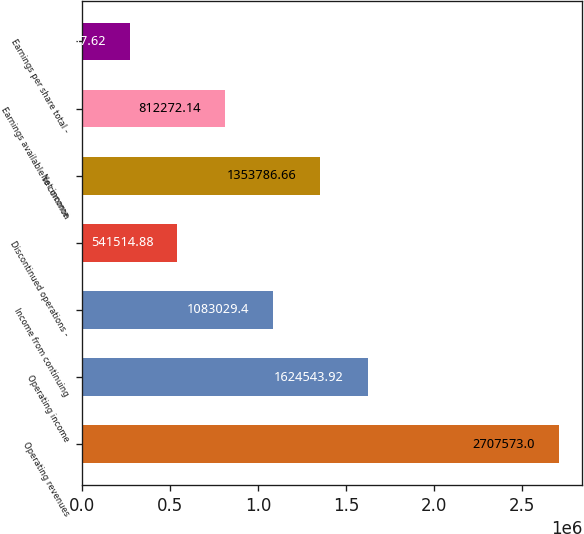Convert chart to OTSL. <chart><loc_0><loc_0><loc_500><loc_500><bar_chart><fcel>Operating revenues<fcel>Operating income<fcel>Income from continuing<fcel>Discontinued operations -<fcel>Net income<fcel>Earnings available to common<fcel>Earnings per share total -<nl><fcel>2.70757e+06<fcel>1.62454e+06<fcel>1.08303e+06<fcel>541515<fcel>1.35379e+06<fcel>812272<fcel>270758<nl></chart> 